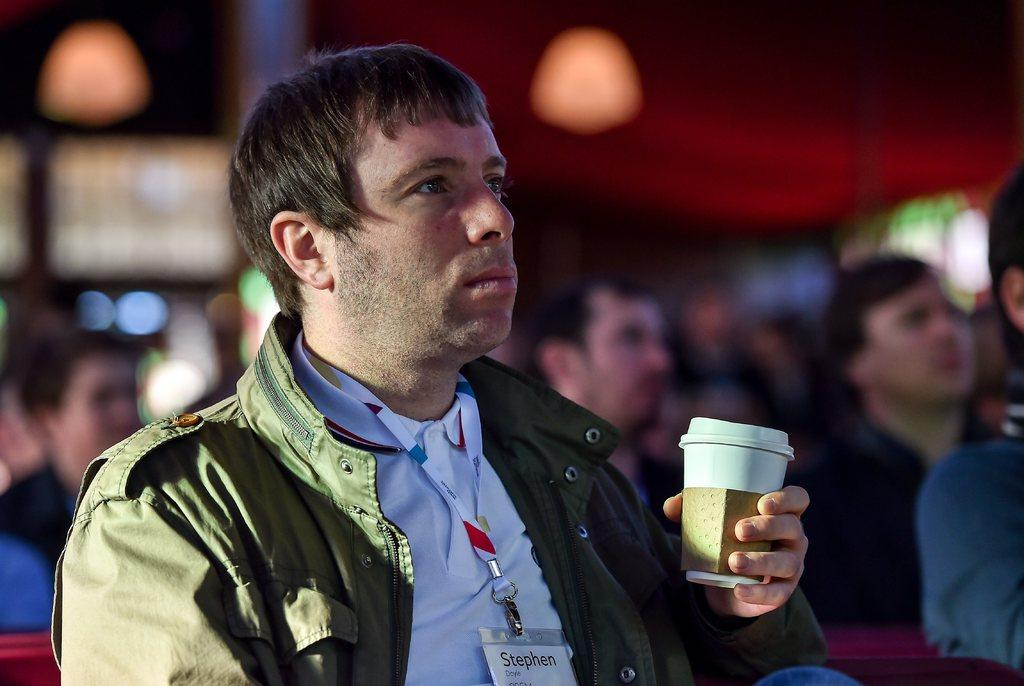What is the main subject of the picture? The main subject of the picture is a man. What is the man holding in his hand? The man is holding a glass in his left hand. What color is the jacket the man is wearing? The man is wearing a green color jacket. Does the man have any identification in the picture? Yes, the man has an id card. What type of rhythm is the man playing on the shirt in the image? There is no shirt or rhythm present in the image; the man is wearing a green color jacket and holding a glass. 